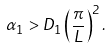Convert formula to latex. <formula><loc_0><loc_0><loc_500><loc_500>\alpha _ { 1 } > D _ { 1 } \left ( \frac { \pi } { L } \right ) ^ { 2 } .</formula> 